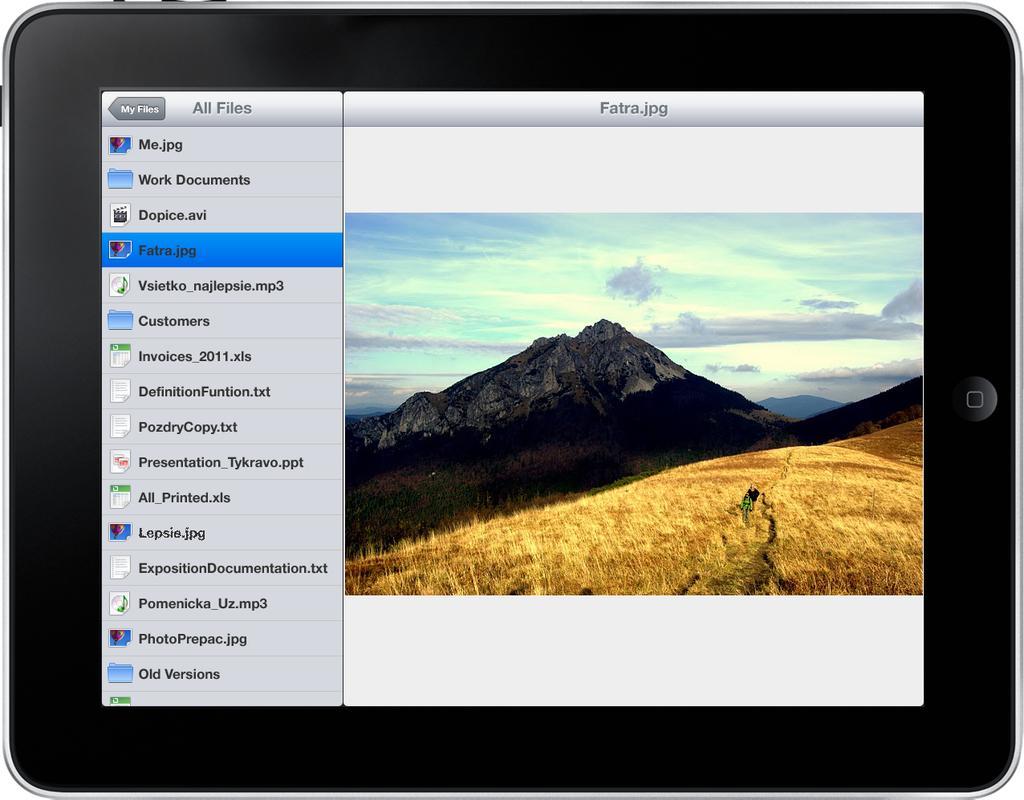Can you describe this image briefly? In this image we can see a gadget, in the electronic gadget there are fields, mountains, sky and text. 